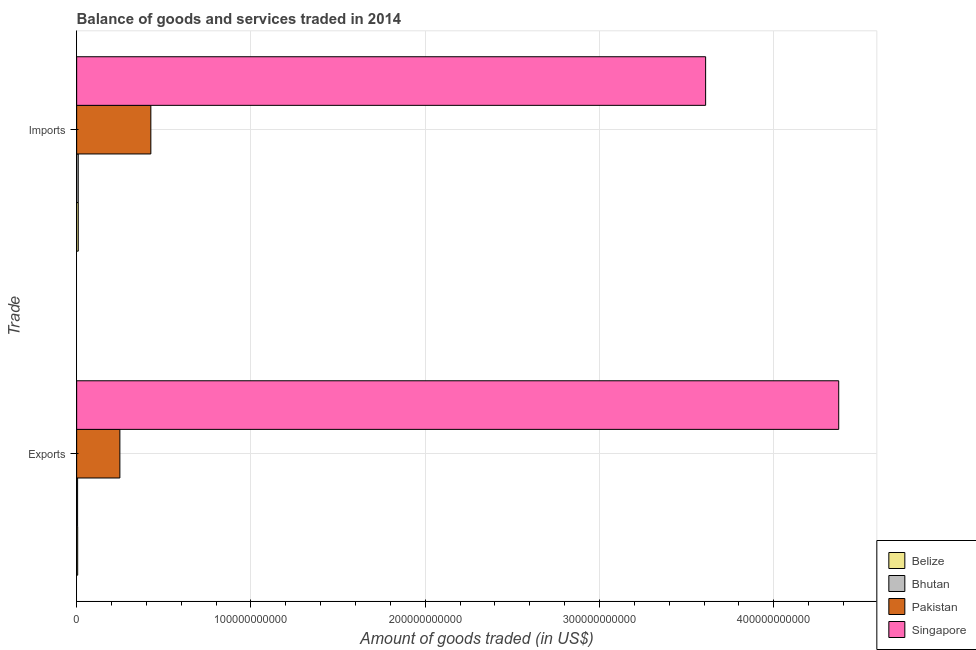How many groups of bars are there?
Make the answer very short. 2. Are the number of bars per tick equal to the number of legend labels?
Your answer should be very brief. Yes. How many bars are there on the 2nd tick from the top?
Ensure brevity in your answer.  4. What is the label of the 1st group of bars from the top?
Your response must be concise. Imports. What is the amount of goods imported in Bhutan?
Provide a succinct answer. 9.01e+08. Across all countries, what is the maximum amount of goods exported?
Offer a terse response. 4.37e+11. Across all countries, what is the minimum amount of goods exported?
Offer a very short reply. 5.35e+08. In which country was the amount of goods exported maximum?
Offer a very short reply. Singapore. In which country was the amount of goods exported minimum?
Your response must be concise. Bhutan. What is the total amount of goods imported in the graph?
Keep it short and to the point. 4.05e+11. What is the difference between the amount of goods exported in Belize and that in Singapore?
Give a very brief answer. -4.37e+11. What is the difference between the amount of goods imported in Bhutan and the amount of goods exported in Pakistan?
Keep it short and to the point. -2.39e+1. What is the average amount of goods imported per country?
Provide a short and direct response. 1.01e+11. What is the difference between the amount of goods imported and amount of goods exported in Belize?
Provide a short and direct response. 3.37e+08. What is the ratio of the amount of goods exported in Belize to that in Pakistan?
Keep it short and to the point. 0.02. In how many countries, is the amount of goods imported greater than the average amount of goods imported taken over all countries?
Ensure brevity in your answer.  1. What does the 3rd bar from the top in Exports represents?
Keep it short and to the point. Bhutan. What does the 1st bar from the bottom in Exports represents?
Offer a very short reply. Belize. Are all the bars in the graph horizontal?
Offer a terse response. Yes. How many countries are there in the graph?
Provide a short and direct response. 4. What is the difference between two consecutive major ticks on the X-axis?
Offer a very short reply. 1.00e+11. Are the values on the major ticks of X-axis written in scientific E-notation?
Your response must be concise. No. Does the graph contain any zero values?
Offer a terse response. No. How are the legend labels stacked?
Provide a short and direct response. Vertical. What is the title of the graph?
Make the answer very short. Balance of goods and services traded in 2014. Does "Aruba" appear as one of the legend labels in the graph?
Offer a very short reply. No. What is the label or title of the X-axis?
Offer a terse response. Amount of goods traded (in US$). What is the label or title of the Y-axis?
Your answer should be compact. Trade. What is the Amount of goods traded (in US$) of Belize in Exports?
Your answer should be compact. 5.89e+08. What is the Amount of goods traded (in US$) of Bhutan in Exports?
Your answer should be compact. 5.35e+08. What is the Amount of goods traded (in US$) in Pakistan in Exports?
Your answer should be compact. 2.48e+1. What is the Amount of goods traded (in US$) of Singapore in Exports?
Make the answer very short. 4.37e+11. What is the Amount of goods traded (in US$) in Belize in Imports?
Ensure brevity in your answer.  9.26e+08. What is the Amount of goods traded (in US$) in Bhutan in Imports?
Ensure brevity in your answer.  9.01e+08. What is the Amount of goods traded (in US$) of Pakistan in Imports?
Ensure brevity in your answer.  4.26e+1. What is the Amount of goods traded (in US$) of Singapore in Imports?
Your response must be concise. 3.61e+11. Across all Trade, what is the maximum Amount of goods traded (in US$) in Belize?
Keep it short and to the point. 9.26e+08. Across all Trade, what is the maximum Amount of goods traded (in US$) in Bhutan?
Your answer should be compact. 9.01e+08. Across all Trade, what is the maximum Amount of goods traded (in US$) in Pakistan?
Your response must be concise. 4.26e+1. Across all Trade, what is the maximum Amount of goods traded (in US$) in Singapore?
Provide a short and direct response. 4.37e+11. Across all Trade, what is the minimum Amount of goods traded (in US$) in Belize?
Your answer should be compact. 5.89e+08. Across all Trade, what is the minimum Amount of goods traded (in US$) of Bhutan?
Ensure brevity in your answer.  5.35e+08. Across all Trade, what is the minimum Amount of goods traded (in US$) of Pakistan?
Offer a terse response. 2.48e+1. Across all Trade, what is the minimum Amount of goods traded (in US$) of Singapore?
Offer a terse response. 3.61e+11. What is the total Amount of goods traded (in US$) in Belize in the graph?
Your response must be concise. 1.51e+09. What is the total Amount of goods traded (in US$) of Bhutan in the graph?
Your answer should be compact. 1.44e+09. What is the total Amount of goods traded (in US$) in Pakistan in the graph?
Offer a very short reply. 6.74e+1. What is the total Amount of goods traded (in US$) in Singapore in the graph?
Your answer should be compact. 7.98e+11. What is the difference between the Amount of goods traded (in US$) of Belize in Exports and that in Imports?
Your answer should be compact. -3.37e+08. What is the difference between the Amount of goods traded (in US$) of Bhutan in Exports and that in Imports?
Offer a very short reply. -3.66e+08. What is the difference between the Amount of goods traded (in US$) of Pakistan in Exports and that in Imports?
Your response must be concise. -1.78e+1. What is the difference between the Amount of goods traded (in US$) in Singapore in Exports and that in Imports?
Offer a terse response. 7.64e+1. What is the difference between the Amount of goods traded (in US$) in Belize in Exports and the Amount of goods traded (in US$) in Bhutan in Imports?
Give a very brief answer. -3.12e+08. What is the difference between the Amount of goods traded (in US$) in Belize in Exports and the Amount of goods traded (in US$) in Pakistan in Imports?
Make the answer very short. -4.20e+1. What is the difference between the Amount of goods traded (in US$) in Belize in Exports and the Amount of goods traded (in US$) in Singapore in Imports?
Keep it short and to the point. -3.60e+11. What is the difference between the Amount of goods traded (in US$) of Bhutan in Exports and the Amount of goods traded (in US$) of Pakistan in Imports?
Keep it short and to the point. -4.20e+1. What is the difference between the Amount of goods traded (in US$) of Bhutan in Exports and the Amount of goods traded (in US$) of Singapore in Imports?
Make the answer very short. -3.60e+11. What is the difference between the Amount of goods traded (in US$) in Pakistan in Exports and the Amount of goods traded (in US$) in Singapore in Imports?
Your answer should be very brief. -3.36e+11. What is the average Amount of goods traded (in US$) of Belize per Trade?
Your response must be concise. 7.57e+08. What is the average Amount of goods traded (in US$) of Bhutan per Trade?
Offer a very short reply. 7.18e+08. What is the average Amount of goods traded (in US$) of Pakistan per Trade?
Make the answer very short. 3.37e+1. What is the average Amount of goods traded (in US$) of Singapore per Trade?
Keep it short and to the point. 3.99e+11. What is the difference between the Amount of goods traded (in US$) in Belize and Amount of goods traded (in US$) in Bhutan in Exports?
Offer a very short reply. 5.40e+07. What is the difference between the Amount of goods traded (in US$) in Belize and Amount of goods traded (in US$) in Pakistan in Exports?
Provide a succinct answer. -2.42e+1. What is the difference between the Amount of goods traded (in US$) of Belize and Amount of goods traded (in US$) of Singapore in Exports?
Provide a succinct answer. -4.37e+11. What is the difference between the Amount of goods traded (in US$) in Bhutan and Amount of goods traded (in US$) in Pakistan in Exports?
Give a very brief answer. -2.43e+1. What is the difference between the Amount of goods traded (in US$) in Bhutan and Amount of goods traded (in US$) in Singapore in Exports?
Keep it short and to the point. -4.37e+11. What is the difference between the Amount of goods traded (in US$) of Pakistan and Amount of goods traded (in US$) of Singapore in Exports?
Give a very brief answer. -4.12e+11. What is the difference between the Amount of goods traded (in US$) of Belize and Amount of goods traded (in US$) of Bhutan in Imports?
Keep it short and to the point. 2.50e+07. What is the difference between the Amount of goods traded (in US$) in Belize and Amount of goods traded (in US$) in Pakistan in Imports?
Your answer should be very brief. -4.16e+1. What is the difference between the Amount of goods traded (in US$) in Belize and Amount of goods traded (in US$) in Singapore in Imports?
Offer a very short reply. -3.60e+11. What is the difference between the Amount of goods traded (in US$) in Bhutan and Amount of goods traded (in US$) in Pakistan in Imports?
Your response must be concise. -4.17e+1. What is the difference between the Amount of goods traded (in US$) in Bhutan and Amount of goods traded (in US$) in Singapore in Imports?
Your answer should be very brief. -3.60e+11. What is the difference between the Amount of goods traded (in US$) in Pakistan and Amount of goods traded (in US$) in Singapore in Imports?
Your response must be concise. -3.18e+11. What is the ratio of the Amount of goods traded (in US$) of Belize in Exports to that in Imports?
Keep it short and to the point. 0.64. What is the ratio of the Amount of goods traded (in US$) of Bhutan in Exports to that in Imports?
Ensure brevity in your answer.  0.59. What is the ratio of the Amount of goods traded (in US$) in Pakistan in Exports to that in Imports?
Your response must be concise. 0.58. What is the ratio of the Amount of goods traded (in US$) in Singapore in Exports to that in Imports?
Your answer should be very brief. 1.21. What is the difference between the highest and the second highest Amount of goods traded (in US$) of Belize?
Your answer should be very brief. 3.37e+08. What is the difference between the highest and the second highest Amount of goods traded (in US$) in Bhutan?
Offer a terse response. 3.66e+08. What is the difference between the highest and the second highest Amount of goods traded (in US$) in Pakistan?
Offer a terse response. 1.78e+1. What is the difference between the highest and the second highest Amount of goods traded (in US$) in Singapore?
Provide a succinct answer. 7.64e+1. What is the difference between the highest and the lowest Amount of goods traded (in US$) of Belize?
Your answer should be compact. 3.37e+08. What is the difference between the highest and the lowest Amount of goods traded (in US$) in Bhutan?
Give a very brief answer. 3.66e+08. What is the difference between the highest and the lowest Amount of goods traded (in US$) in Pakistan?
Your answer should be compact. 1.78e+1. What is the difference between the highest and the lowest Amount of goods traded (in US$) in Singapore?
Give a very brief answer. 7.64e+1. 